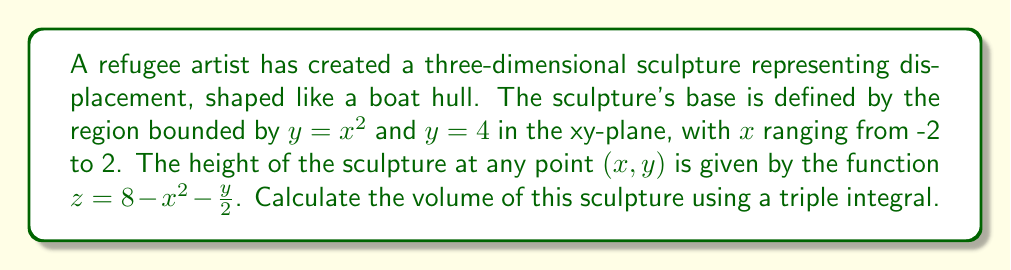Can you answer this question? To calculate the volume of the sculpture, we need to set up and evaluate a triple integral. Let's approach this step-by-step:

1) The region of integration in the xy-plane is bounded by $y = x^2$ and $y = 4$, with $x$ ranging from -2 to 2. This suggests we should use $x$ as our outermost integral.

2) For a given $x$, $y$ ranges from $x^2$ to 4.

3) For each $(x, y)$ point, $z$ ranges from 0 to $8 - x^2 - \frac{y}{2}$.

4) Therefore, our triple integral will be:

   $$V = \int_{-2}^{2} \int_{x^2}^{4} \int_{0}^{8 - x^2 - \frac{y}{2}} dz \, dy \, dx$$

5) Let's evaluate the innermost integral first:

   $$\int_{0}^{8 - x^2 - \frac{y}{2}} dz = \left[z\right]_{0}^{8 - x^2 - \frac{y}{2}} = 8 - x^2 - \frac{y}{2}$$

6) Now our double integral becomes:

   $$V = \int_{-2}^{2} \int_{x^2}^{4} (8 - x^2 - \frac{y}{2}) \, dy \, dx$$

7) Evaluate the integral with respect to $y$:

   $$\int_{x^2}^{4} (8 - x^2 - \frac{y}{2}) \, dy = \left[(8 - x^2)y - \frac{y^2}{4}\right]_{x^2}^{4}$$
   $$= \left[(8 - x^2)(4) - \frac{16}{4}\right] - \left[(8 - x^2)(x^2) - \frac{x^4}{4}\right]$$
   $$= 32 - 4x^2 - 4 - (8x^2 - x^4 - \frac{x^4}{4})$$
   $$= 28 - 12x^2 + \frac{3x^4}{4}$$

8) Our final integral is:

   $$V = \int_{-2}^{2} (28 - 12x^2 + \frac{3x^4}{4}) \, dx$$

9) Evaluate this integral:

   $$V = \left[28x - 4x^3 + \frac{3x^5}{20}\right]_{-2}^{2}$$
   $$= \left(56 - 32 + \frac{24}{5}\right) - \left(-56 - 32 - \frac{24}{5}\right)$$
   $$= \frac{280}{5} + \frac{280}{5} = \frac{560}{5} = 112$$

Therefore, the volume of the sculpture is 112 cubic units.
Answer: 112 cubic units 